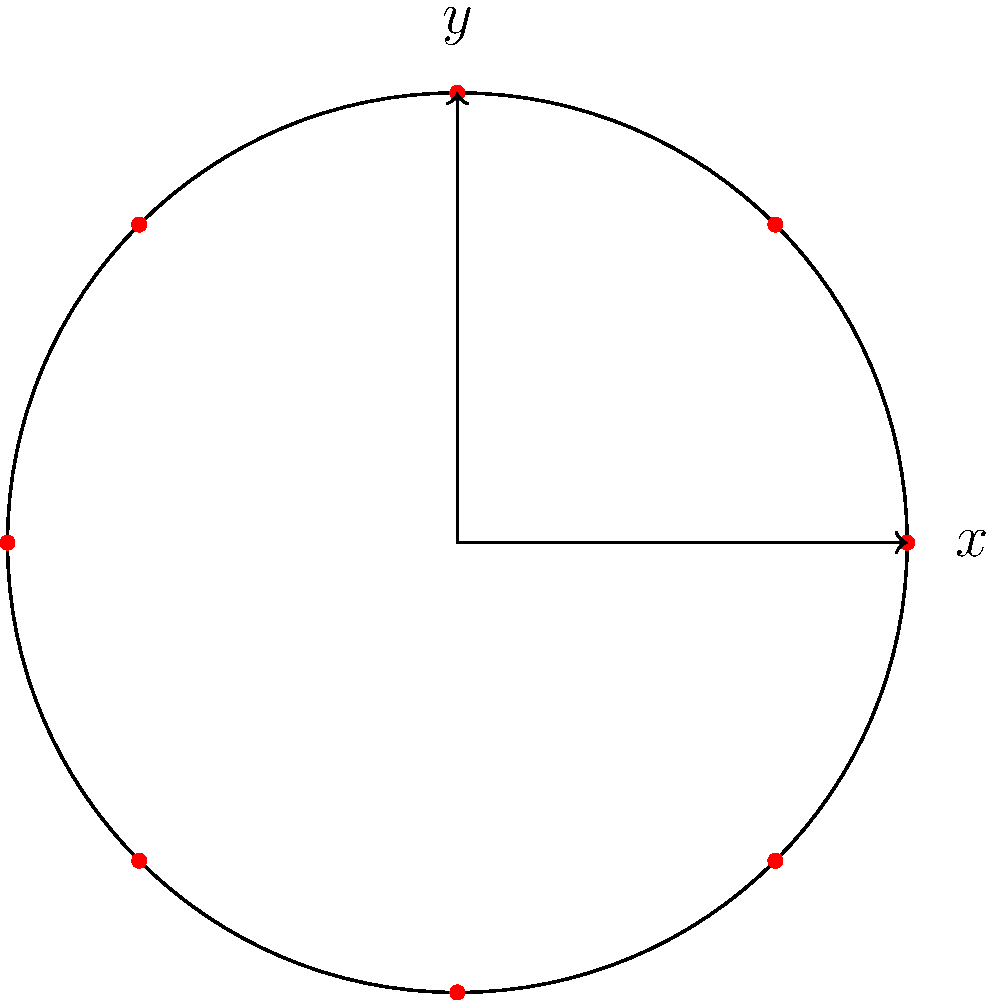You are organizing a circular seating arrangement for 8 participants in a coding seminar. The seats are equally spaced around a circle with a radius of 3 meters. Using polar coordinates, what is the position $(r,\theta)$ of the third participant clockwise from the positive x-axis? Let's approach this step-by-step:

1) In a circle, there are 360° or $2\pi$ radians.

2) With 8 participants, each participant occupies $\frac{2\pi}{8} = \frac{\pi}{4}$ radians.

3) The first participant (at 0°) is on the positive x-axis.

4) The second participant is at $\frac{\pi}{4}$ radians.

5) The third participant, which we're looking for, is at $2 \cdot \frac{\pi}{4} = \frac{\pi}{2}$ radians.

6) In polar coordinates, the radius $r$ is given (3 meters), and we've calculated the angle $\theta$.

Therefore, the position of the third participant in polar coordinates is $(3, \frac{\pi}{2})$.
Answer: $(3, \frac{\pi}{2})$ 